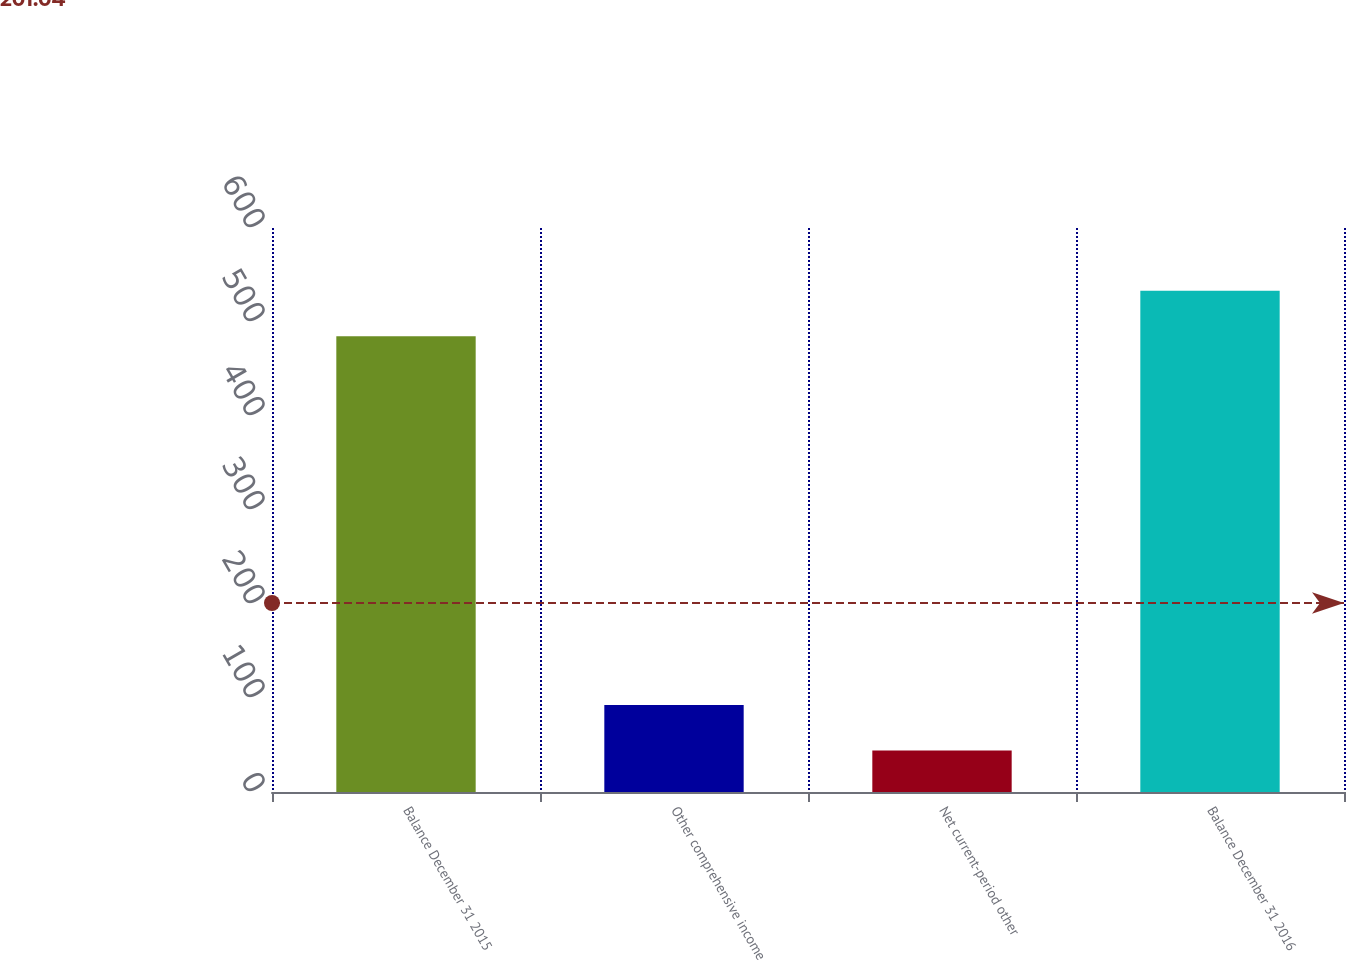Convert chart to OTSL. <chart><loc_0><loc_0><loc_500><loc_500><bar_chart><fcel>Balance December 31 2015<fcel>Other comprehensive income<fcel>Net current-period other<fcel>Balance December 31 2016<nl><fcel>484.8<fcel>92.58<fcel>44.1<fcel>533.28<nl></chart> 